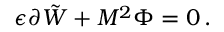<formula> <loc_0><loc_0><loc_500><loc_500>\epsilon \partial \tilde { W } + M ^ { 2 } \Phi = 0 \, .</formula> 